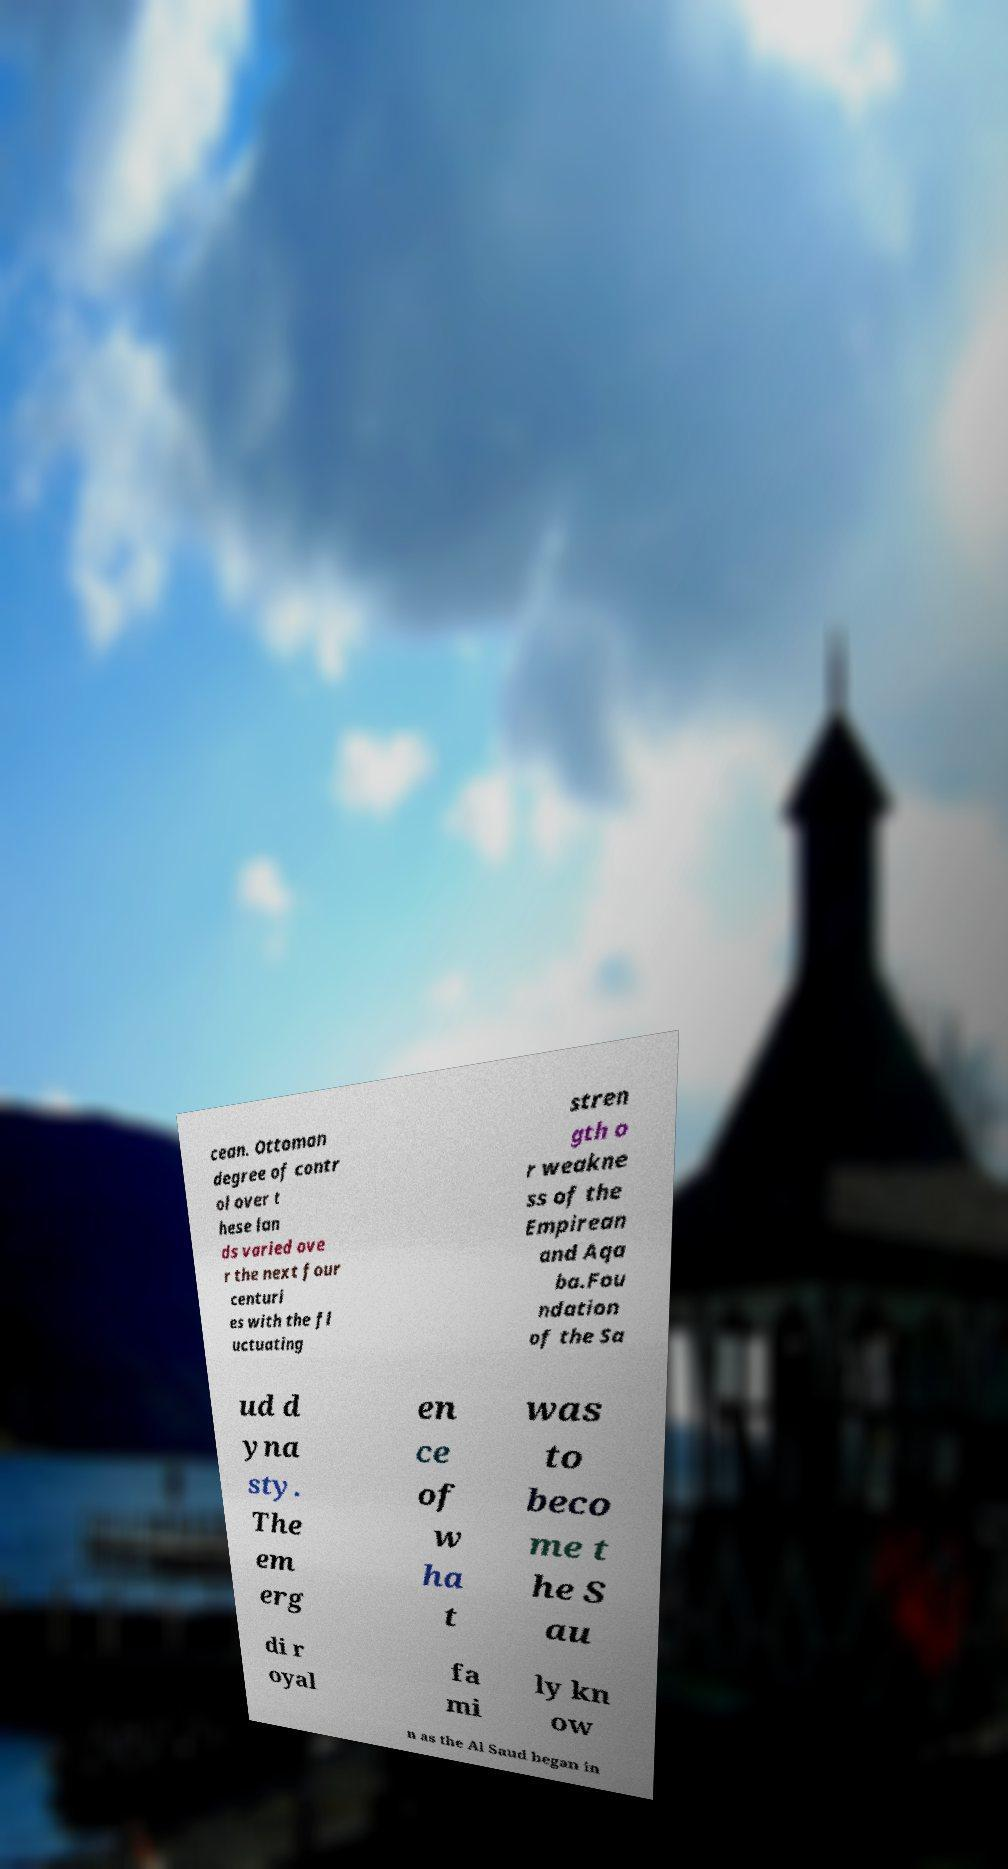Could you extract and type out the text from this image? cean. Ottoman degree of contr ol over t hese lan ds varied ove r the next four centuri es with the fl uctuating stren gth o r weakne ss of the Empirean and Aqa ba.Fou ndation of the Sa ud d yna sty. The em erg en ce of w ha t was to beco me t he S au di r oyal fa mi ly kn ow n as the Al Saud began in 